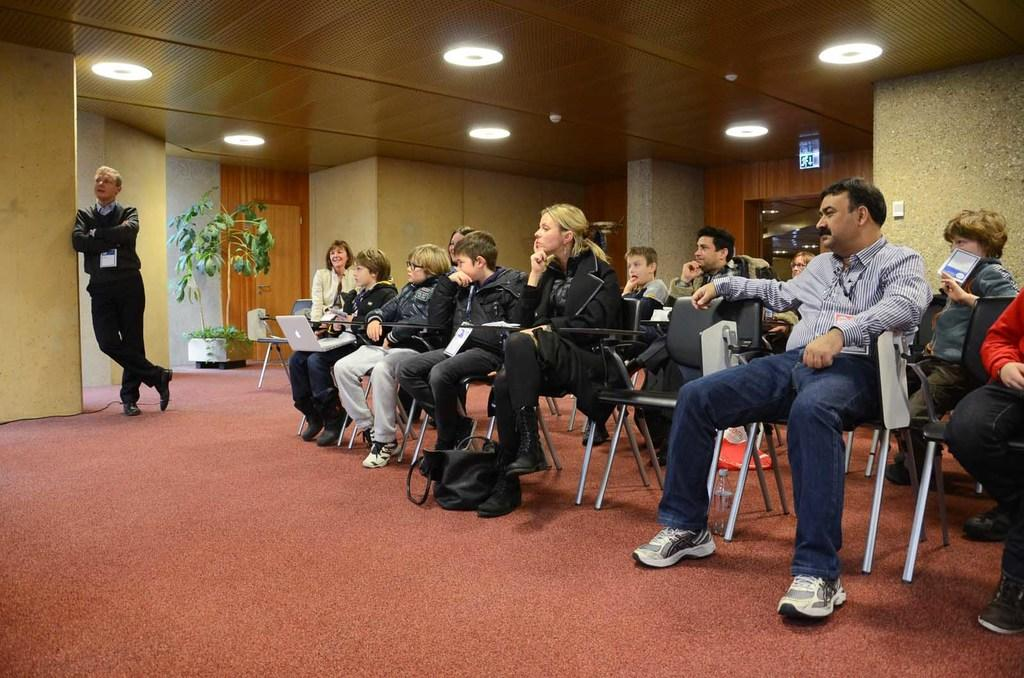What are the people in the image doing? The people in the image are sitting on chairs. What can be seen in the background of the image? There is a wall and a plant in the background of the image. What type of lighting is present in the image? There are lights on the ceiling in the image. What is the man in the image doing? There is a man standing in the image. Can you see any squirrels running around in the image? There are no squirrels present in the image. What type of airport is visible in the image? There is no airport present in the image. 